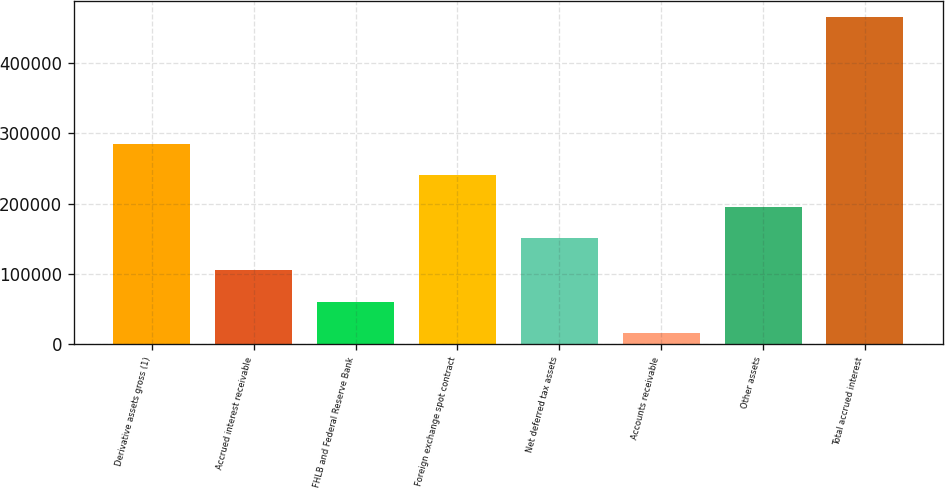Convert chart to OTSL. <chart><loc_0><loc_0><loc_500><loc_500><bar_chart><fcel>Derivative assets gross (1)<fcel>Accrued interest receivable<fcel>FHLB and Federal Reserve Bank<fcel>Foreign exchange spot contract<fcel>Net deferred tax assets<fcel>Accounts receivable<fcel>Other assets<fcel>Total accrued interest<nl><fcel>285375<fcel>105640<fcel>60706.7<fcel>240442<fcel>150574<fcel>15773<fcel>195508<fcel>465110<nl></chart> 